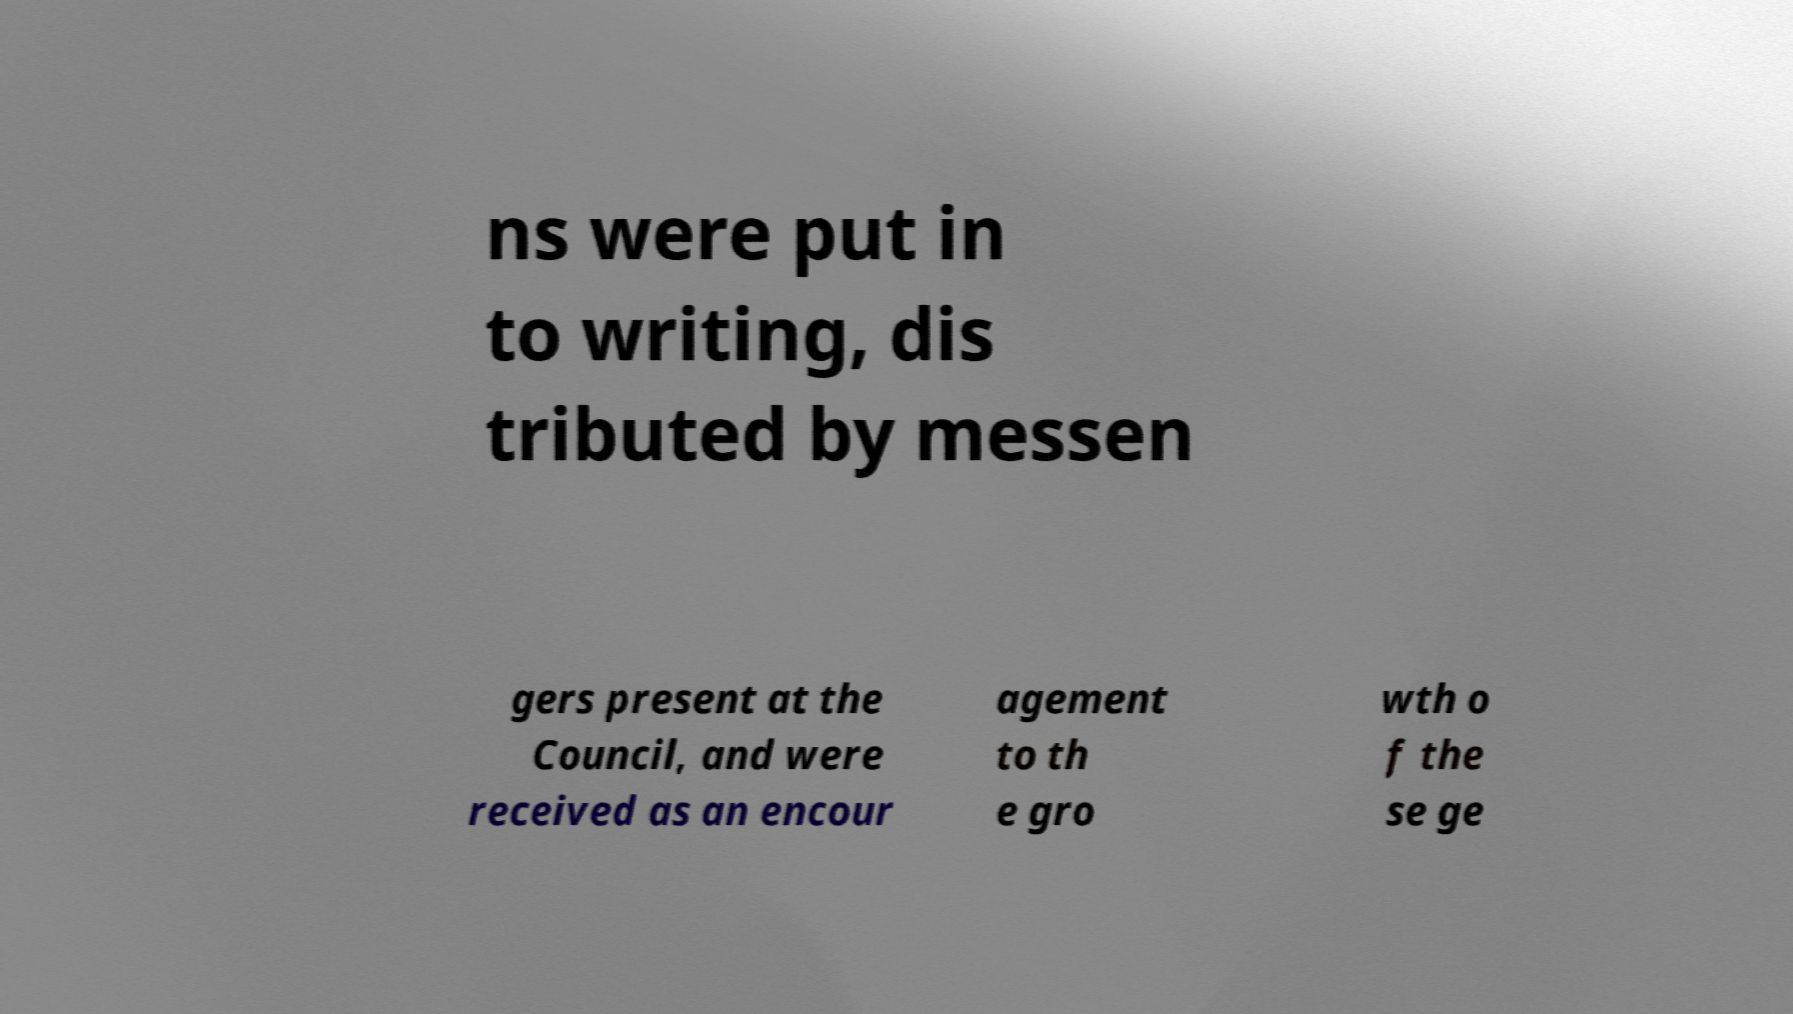Please identify and transcribe the text found in this image. ns were put in to writing, dis tributed by messen gers present at the Council, and were received as an encour agement to th e gro wth o f the se ge 